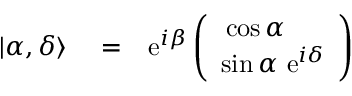Convert formula to latex. <formula><loc_0><loc_0><loc_500><loc_500>\begin{array} { r l r } { | \alpha , \delta \rangle } & = } & { e ^ { i \beta } \left ( \begin{array} { c } { \cos \alpha \quad } \\ { \sin \alpha \ e ^ { i \delta } } \end{array} \right ) } \end{array}</formula> 